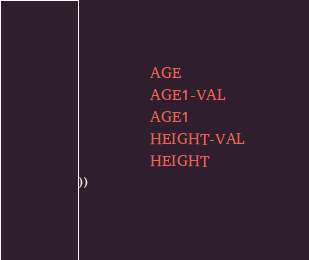<code> <loc_0><loc_0><loc_500><loc_500><_Lisp_>          AGE
          AGE1-VAL
          AGE1
          HEIGHT-VAL
          HEIGHT
))</code> 